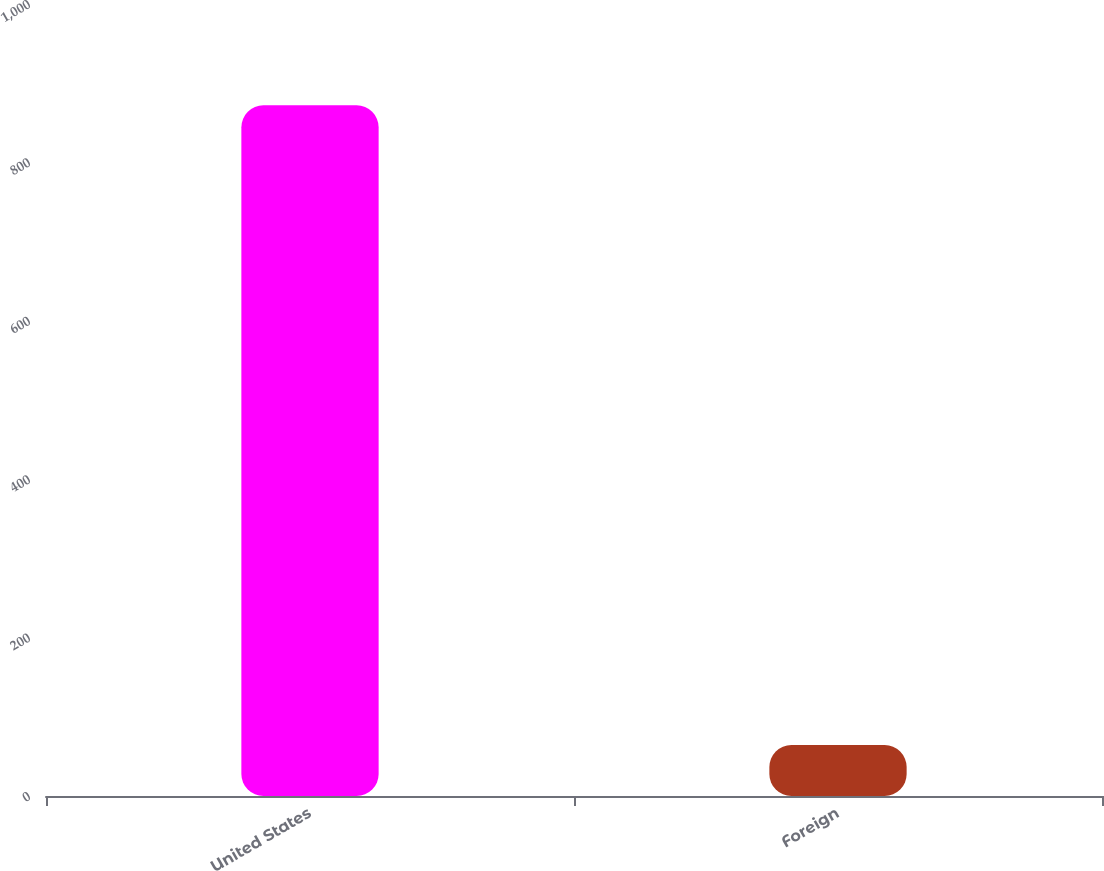<chart> <loc_0><loc_0><loc_500><loc_500><bar_chart><fcel>United States<fcel>Foreign<nl><fcel>872.1<fcel>64.3<nl></chart> 